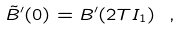<formula> <loc_0><loc_0><loc_500><loc_500>\tilde { B } ^ { \prime } ( 0 ) = B ^ { \prime } ( 2 T I _ { 1 } ) \ ,</formula> 